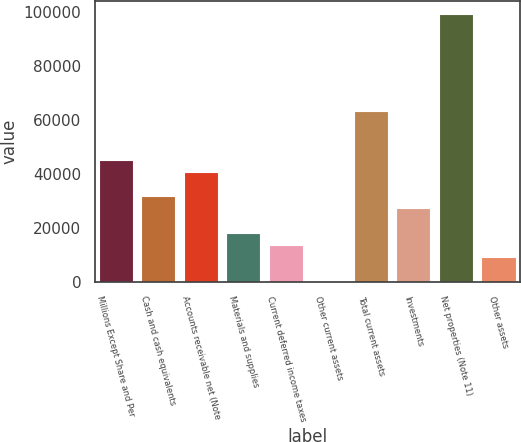Convert chart to OTSL. <chart><loc_0><loc_0><loc_500><loc_500><bar_chart><fcel>Millions Except Share and Per<fcel>Cash and cash equivalents<fcel>Accounts receivable net (Note<fcel>Materials and supplies<fcel>Current deferred income taxes<fcel>Other current assets<fcel>Total current assets<fcel>Investments<fcel>Net properties (Note 11)<fcel>Other assets<nl><fcel>45096<fcel>31623.9<fcel>40605.3<fcel>18151.8<fcel>13661.1<fcel>189<fcel>63058.8<fcel>27133.2<fcel>98984.4<fcel>9170.4<nl></chart> 